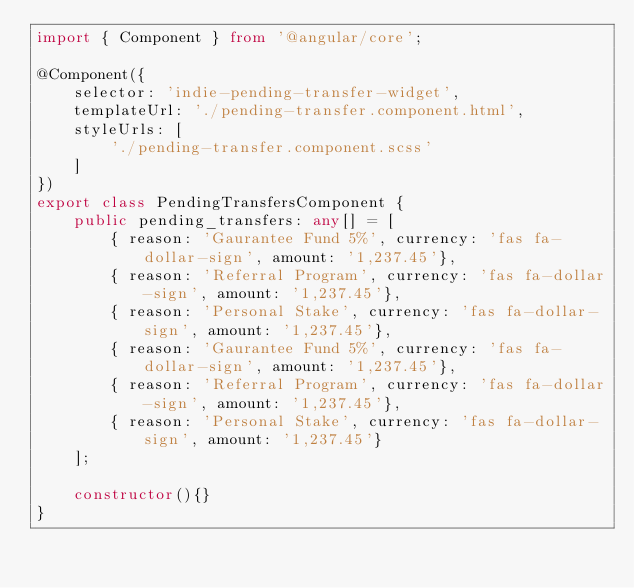Convert code to text. <code><loc_0><loc_0><loc_500><loc_500><_TypeScript_>import { Component } from '@angular/core';

@Component({
    selector: 'indie-pending-transfer-widget',
    templateUrl: './pending-transfer.component.html',
    styleUrls: [
        './pending-transfer.component.scss'
    ]
})
export class PendingTransfersComponent {
    public pending_transfers: any[] = [
        { reason: 'Gaurantee Fund 5%', currency: 'fas fa-dollar-sign', amount: '1,237.45'},
        { reason: 'Referral Program', currency: 'fas fa-dollar-sign', amount: '1,237.45'},
        { reason: 'Personal Stake', currency: 'fas fa-dollar-sign', amount: '1,237.45'},
        { reason: 'Gaurantee Fund 5%', currency: 'fas fa-dollar-sign', amount: '1,237.45'},
        { reason: 'Referral Program', currency: 'fas fa-dollar-sign', amount: '1,237.45'},
        { reason: 'Personal Stake', currency: 'fas fa-dollar-sign', amount: '1,237.45'}
    ];

    constructor(){}    
}</code> 